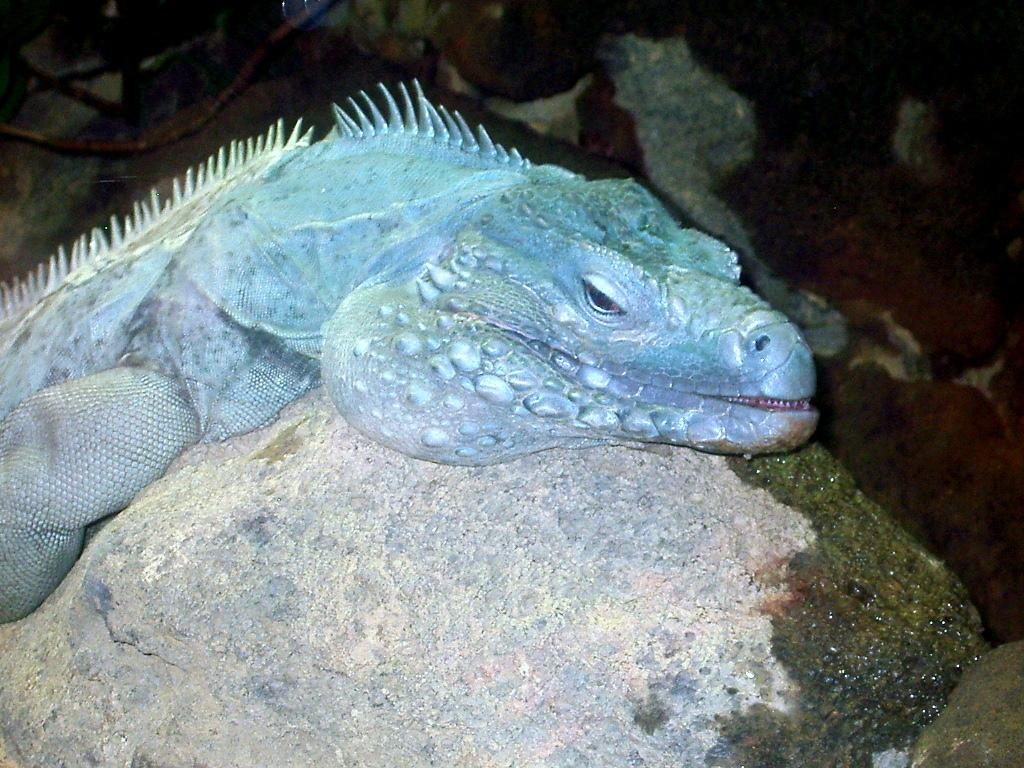What animal is the main subject of the image? There is an alligator in the image. Where is the alligator located in the image? The alligator is on a rock. How does the alligator compare to a washing machine in the image? There is no washing machine present in the image, so it cannot be compared to the alligator. 